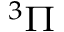Convert formula to latex. <formula><loc_0><loc_0><loc_500><loc_500>^ { 3 } \Pi</formula> 